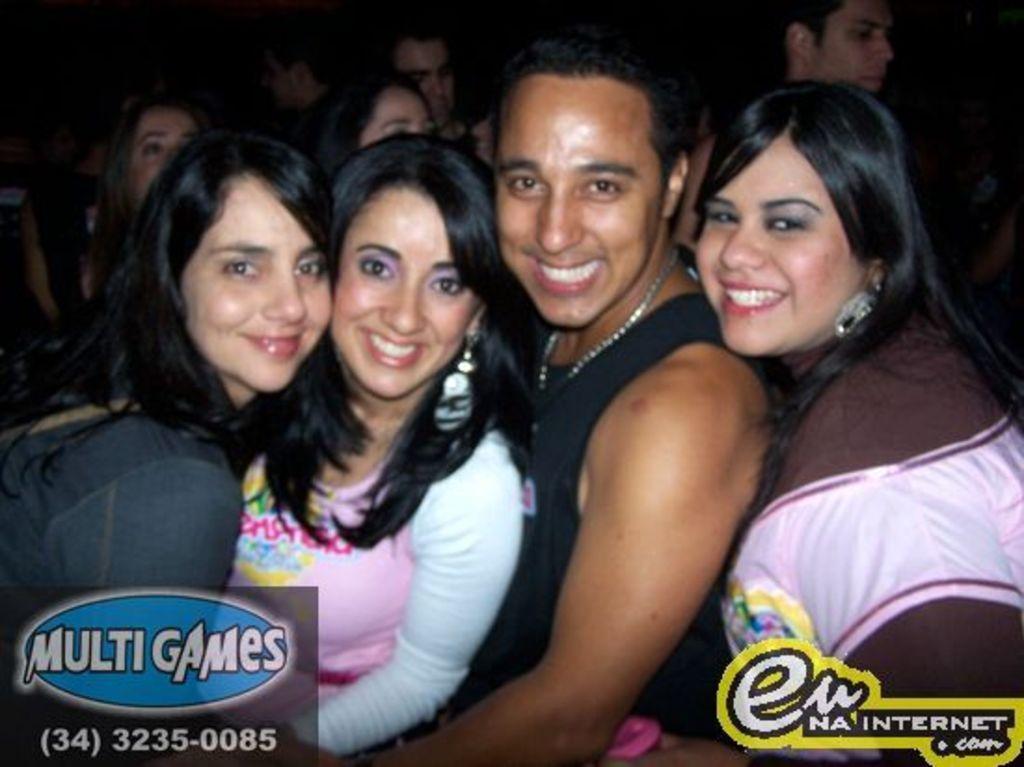In one or two sentences, can you explain what this image depicts? In this image, we can see people smiling and at the bottom, there are logos. 